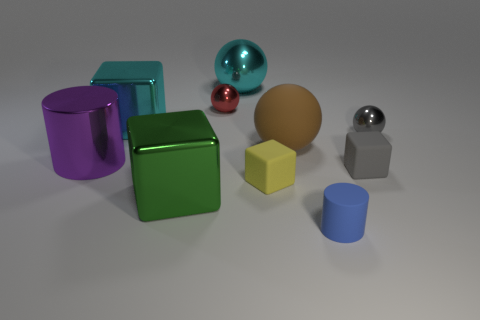Subtract all metallic spheres. How many spheres are left? 1 Subtract all brown spheres. How many spheres are left? 3 Subtract 2 balls. How many balls are left? 2 Subtract all red cubes. Subtract all brown balls. How many cubes are left? 4 Subtract all cylinders. How many objects are left? 8 Add 2 small red blocks. How many small red blocks exist? 2 Subtract 0 yellow cylinders. How many objects are left? 10 Subtract all cyan metallic blocks. Subtract all big cyan shiny objects. How many objects are left? 7 Add 5 yellow matte objects. How many yellow matte objects are left? 6 